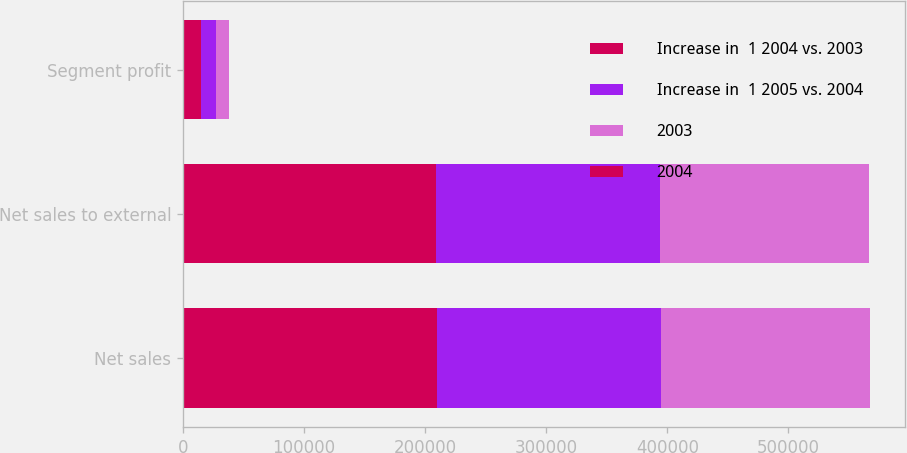<chart> <loc_0><loc_0><loc_500><loc_500><stacked_bar_chart><ecel><fcel>Net sales<fcel>Net sales to external<fcel>Segment profit<nl><fcel>Increase in  1 2004 vs. 2003<fcel>209454<fcel>208895<fcel>14745<nl><fcel>Increase in  1 2005 vs. 2004<fcel>185022<fcel>185325<fcel>12882<nl><fcel>2003<fcel>173004<fcel>172663<fcel>10676<nl><fcel>2004<fcel>13<fcel>13<fcel>14<nl></chart> 